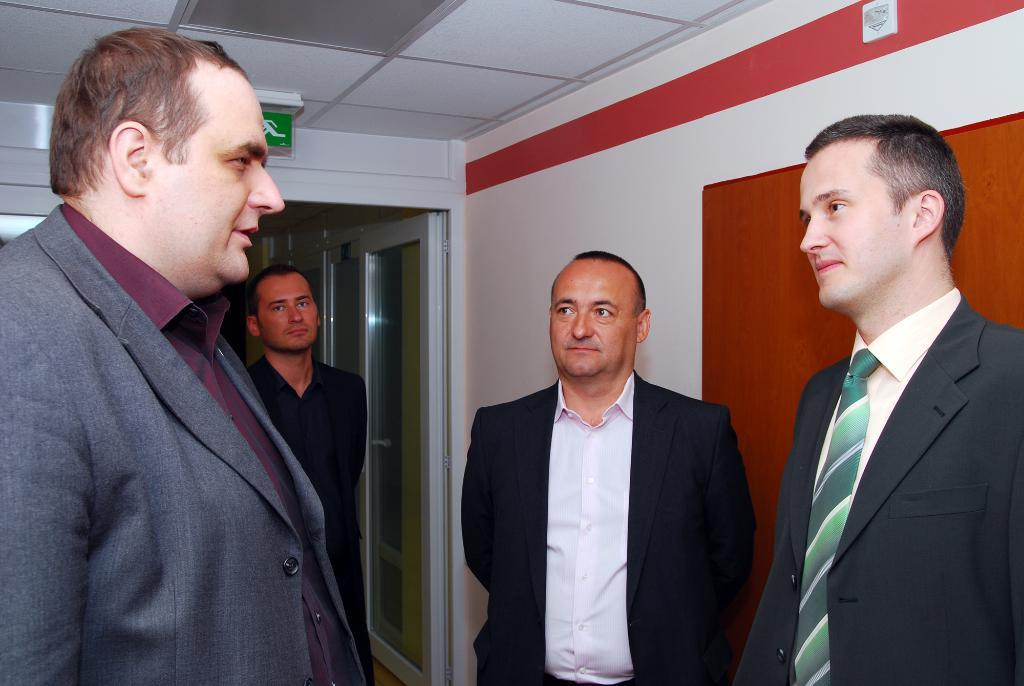Where was the image taken? The image is taken indoors. What is the main subject of the image? There is a group of men in the center of the image. What are the men wearing? The men are wearing suits. What is the men's position in relation to the ground? The men are standing on the ground. What can be seen in the background of the image? There is a door, a roof, and a wall visible in the background. What type of car is the man driving in the image? There is no car or driving activity present in the image. What is the man's mouth doing in the image? There is no specific focus on the men's mouths in the image; they are simply standing and wearing suits. 